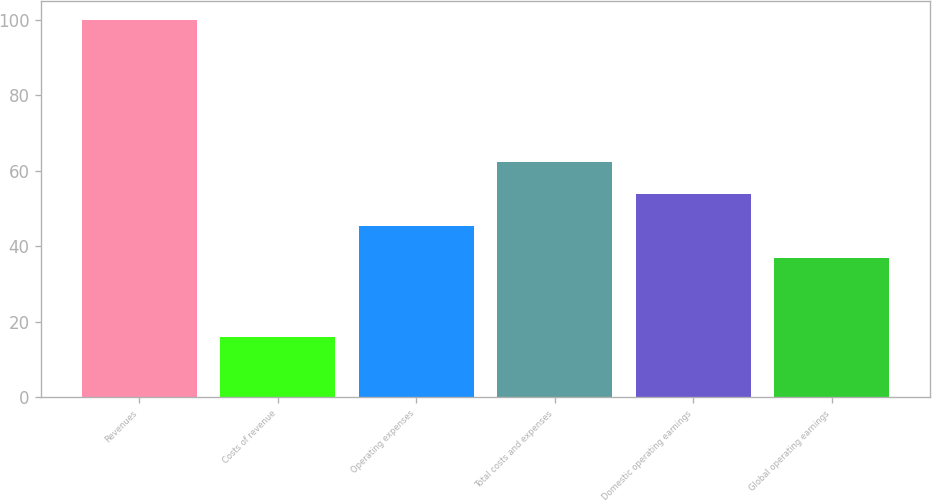Convert chart. <chart><loc_0><loc_0><loc_500><loc_500><bar_chart><fcel>Revenues<fcel>Costs of revenue<fcel>Operating expenses<fcel>Total costs and expenses<fcel>Domestic operating earnings<fcel>Global operating earnings<nl><fcel>100<fcel>16<fcel>45.4<fcel>62.2<fcel>53.8<fcel>37<nl></chart> 